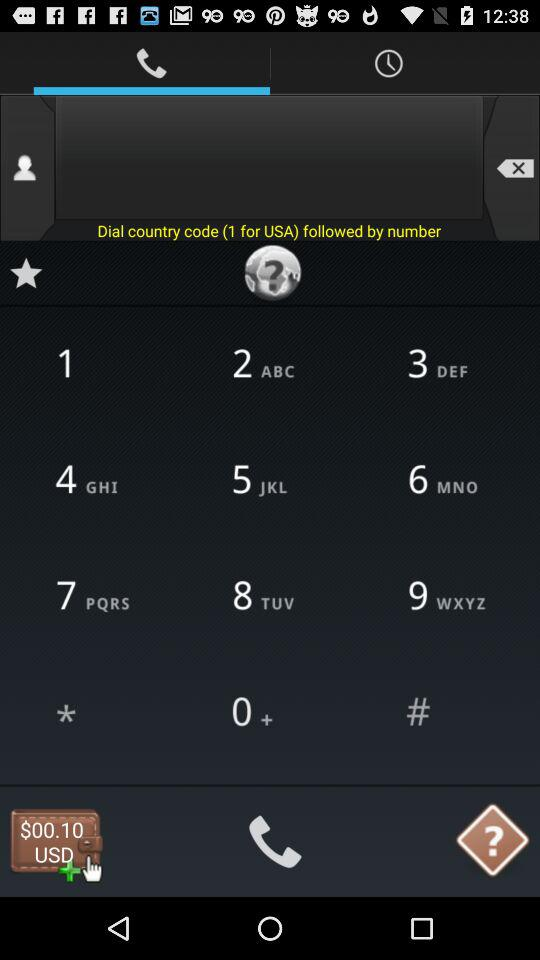What is the price? The price is 0.10 USD. 